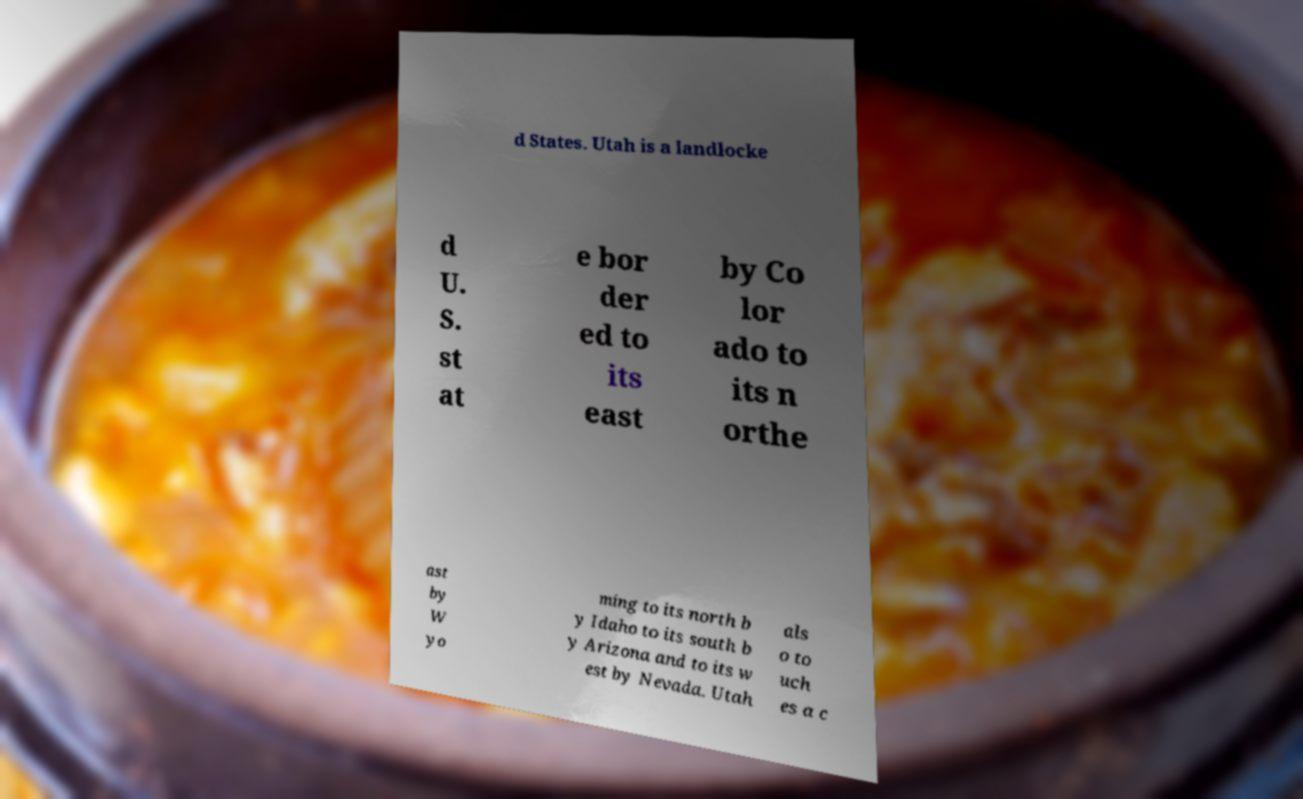I need the written content from this picture converted into text. Can you do that? d States. Utah is a landlocke d U. S. st at e bor der ed to its east by Co lor ado to its n orthe ast by W yo ming to its north b y Idaho to its south b y Arizona and to its w est by Nevada. Utah als o to uch es a c 